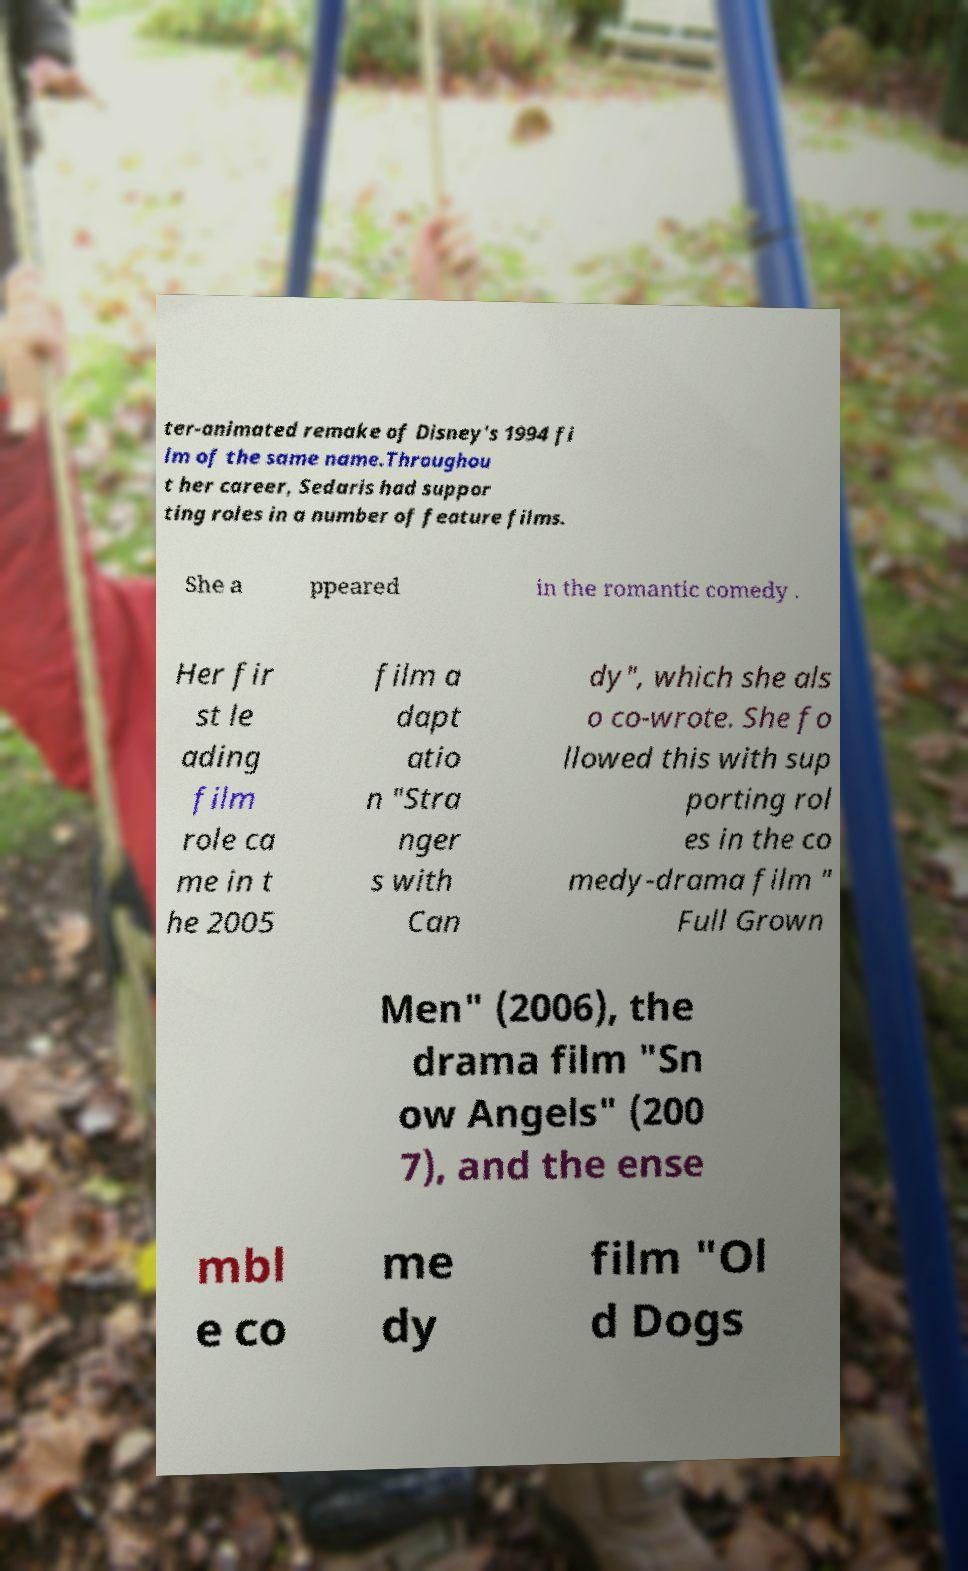I need the written content from this picture converted into text. Can you do that? ter-animated remake of Disney's 1994 fi lm of the same name.Throughou t her career, Sedaris had suppor ting roles in a number of feature films. She a ppeared in the romantic comedy . Her fir st le ading film role ca me in t he 2005 film a dapt atio n "Stra nger s with Can dy", which she als o co-wrote. She fo llowed this with sup porting rol es in the co medy-drama film " Full Grown Men" (2006), the drama film "Sn ow Angels" (200 7), and the ense mbl e co me dy film "Ol d Dogs 